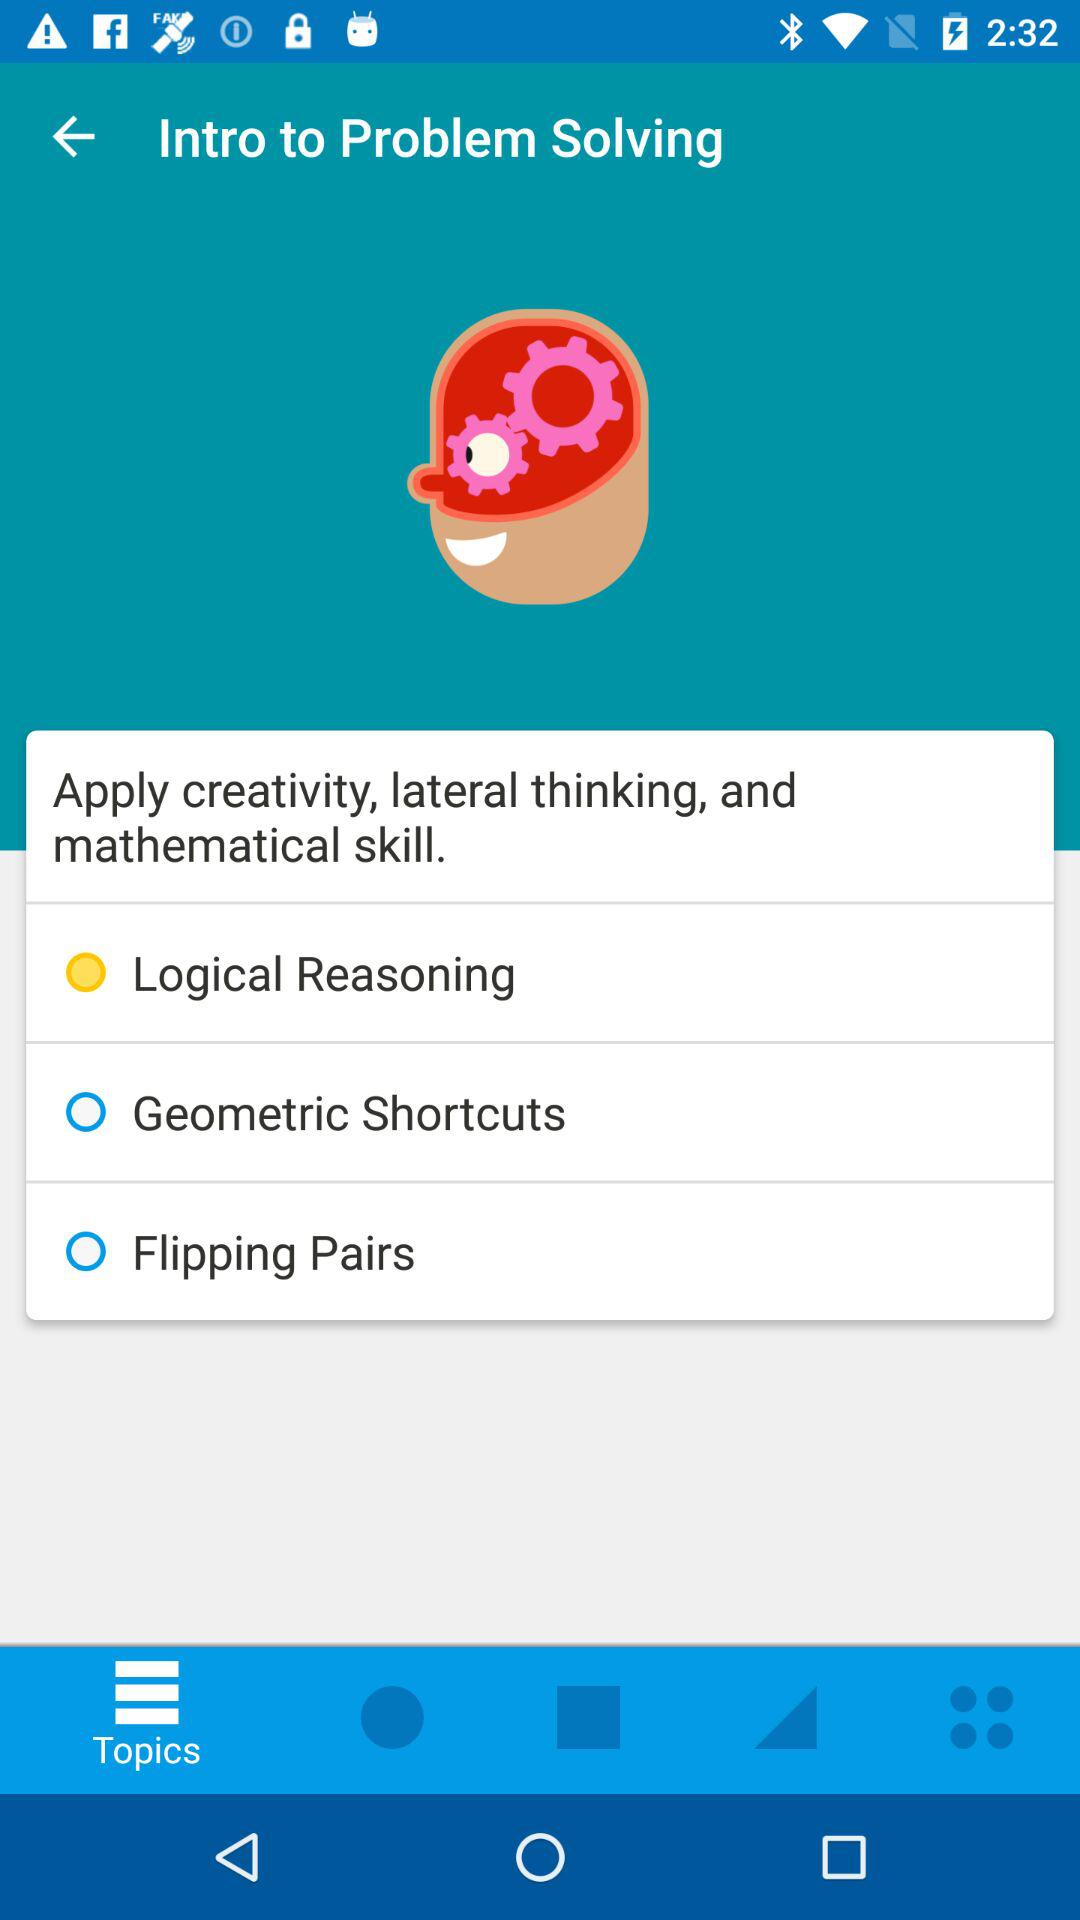Which tab is selected? The selected tab is "Topics". 